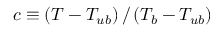Convert formula to latex. <formula><loc_0><loc_0><loc_500><loc_500>c \equiv \left ( T - T _ { u b } \right ) / \left ( T _ { b } - T _ { u b } \right )</formula> 